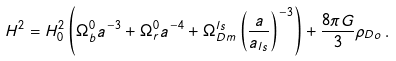<formula> <loc_0><loc_0><loc_500><loc_500>H ^ { 2 } = H _ { 0 } ^ { 2 } \left ( \Omega ^ { 0 } _ { b } a ^ { - 3 } + \Omega ^ { 0 } _ { r } a ^ { - 4 } + \Omega ^ { l s } _ { D m } \left ( \frac { a } { a _ { l s } } \right ) ^ { - 3 } \right ) + \frac { 8 \pi G } { 3 } \rho _ { D o } \, .</formula> 